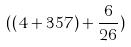<formula> <loc_0><loc_0><loc_500><loc_500>( ( 4 + 3 5 7 ) + \frac { 6 } { 2 6 } )</formula> 